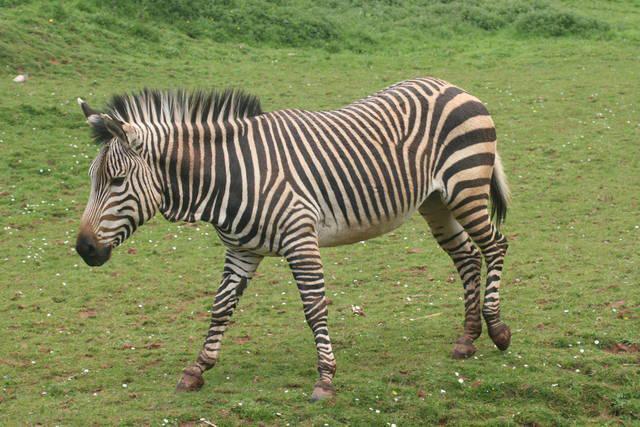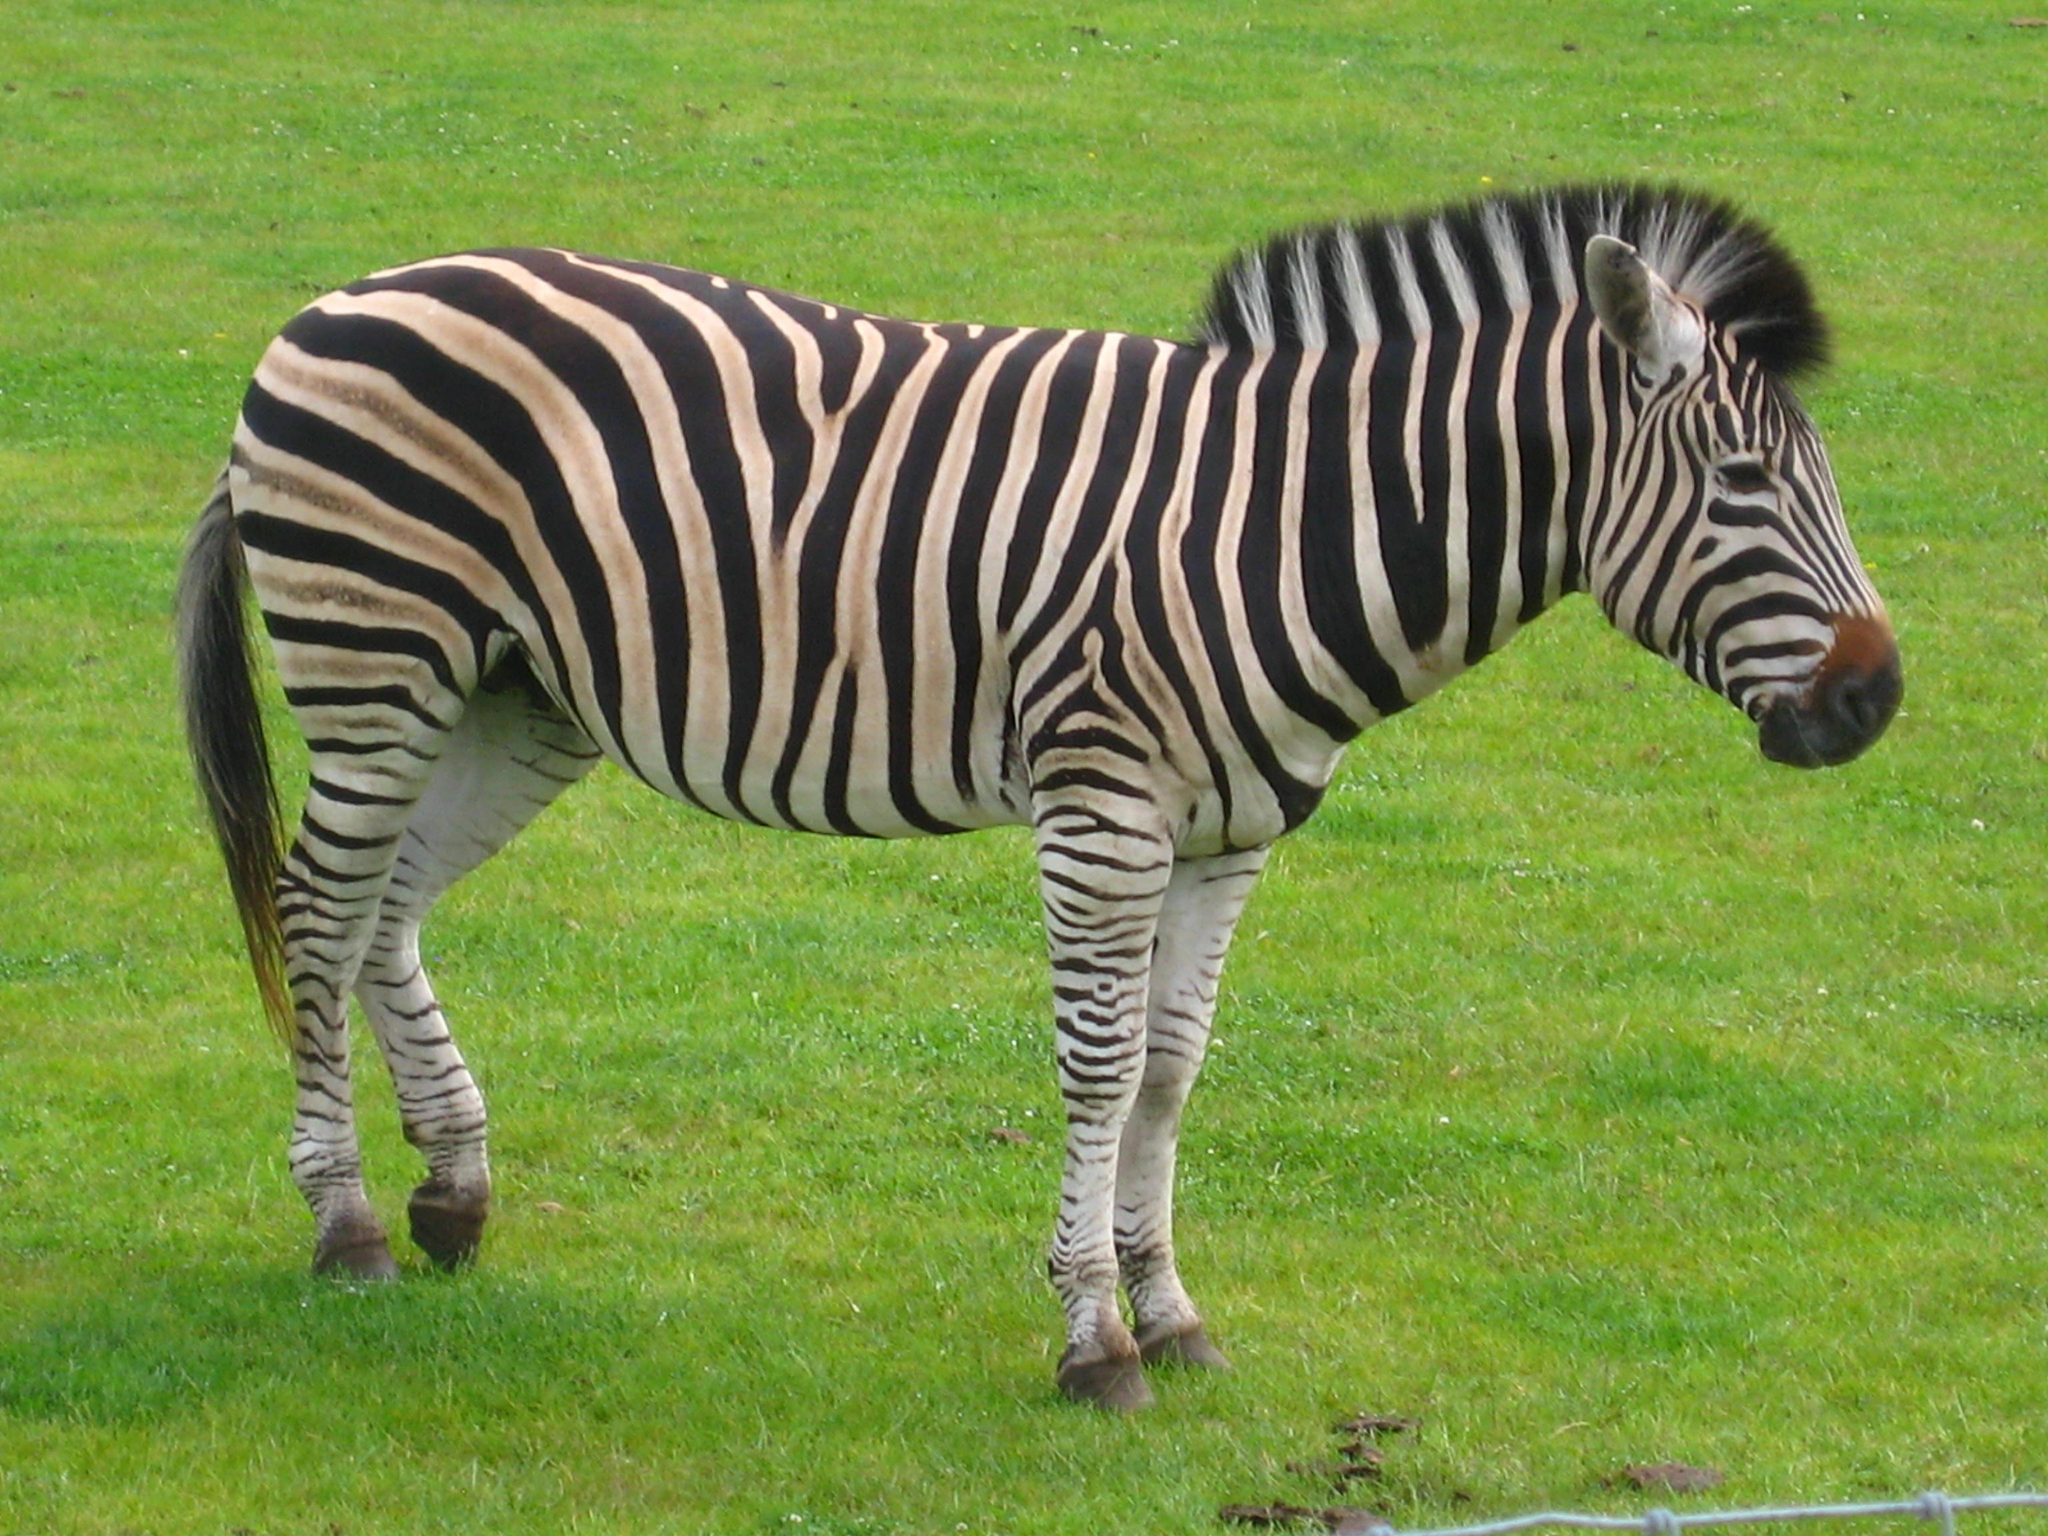The first image is the image on the left, the second image is the image on the right. Analyze the images presented: Is the assertion "No more than three zebra are shown in total, and the right image contains a single zebra standing with its head and body in profile." valid? Answer yes or no. Yes. The first image is the image on the left, the second image is the image on the right. Analyze the images presented: Is the assertion "The left image contains exactly two zebras." valid? Answer yes or no. No. 